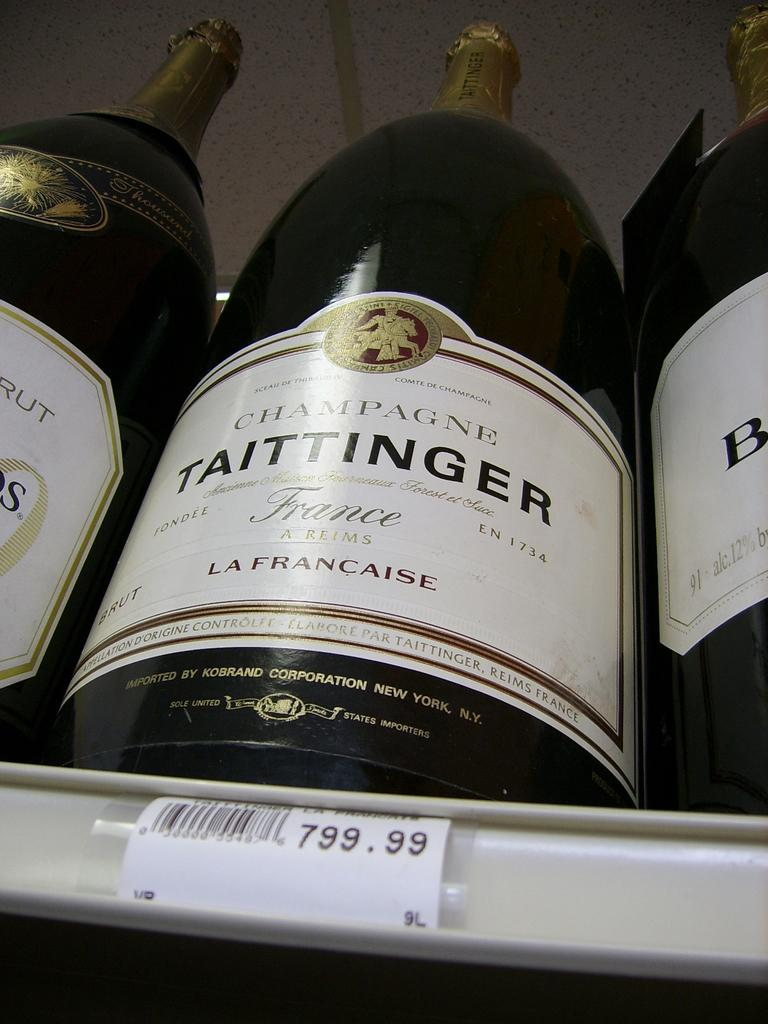<image>
Present a compact description of the photo's key features. A bottle of Taittinger wine sells for 799.99. 